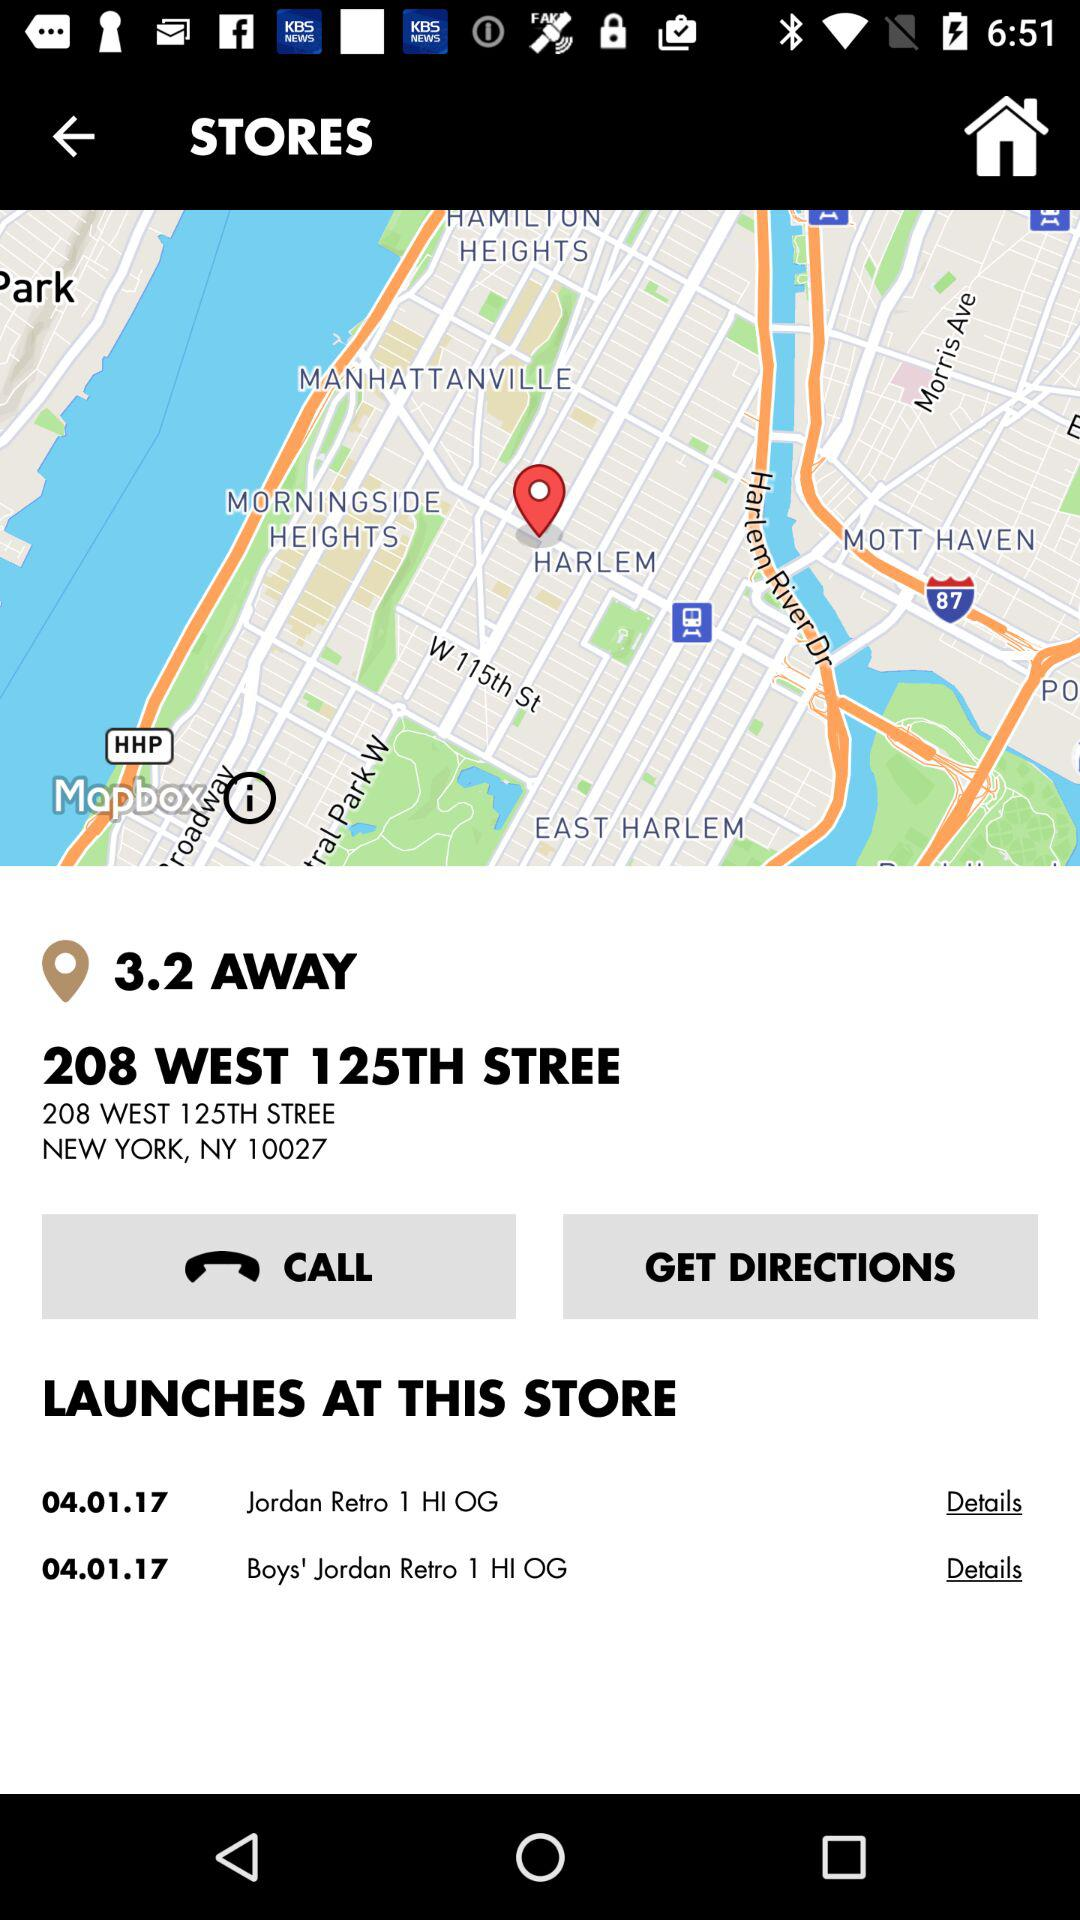What's the location of the store? The location of the store is 208 West 125th Street, New York, NY 10027. 